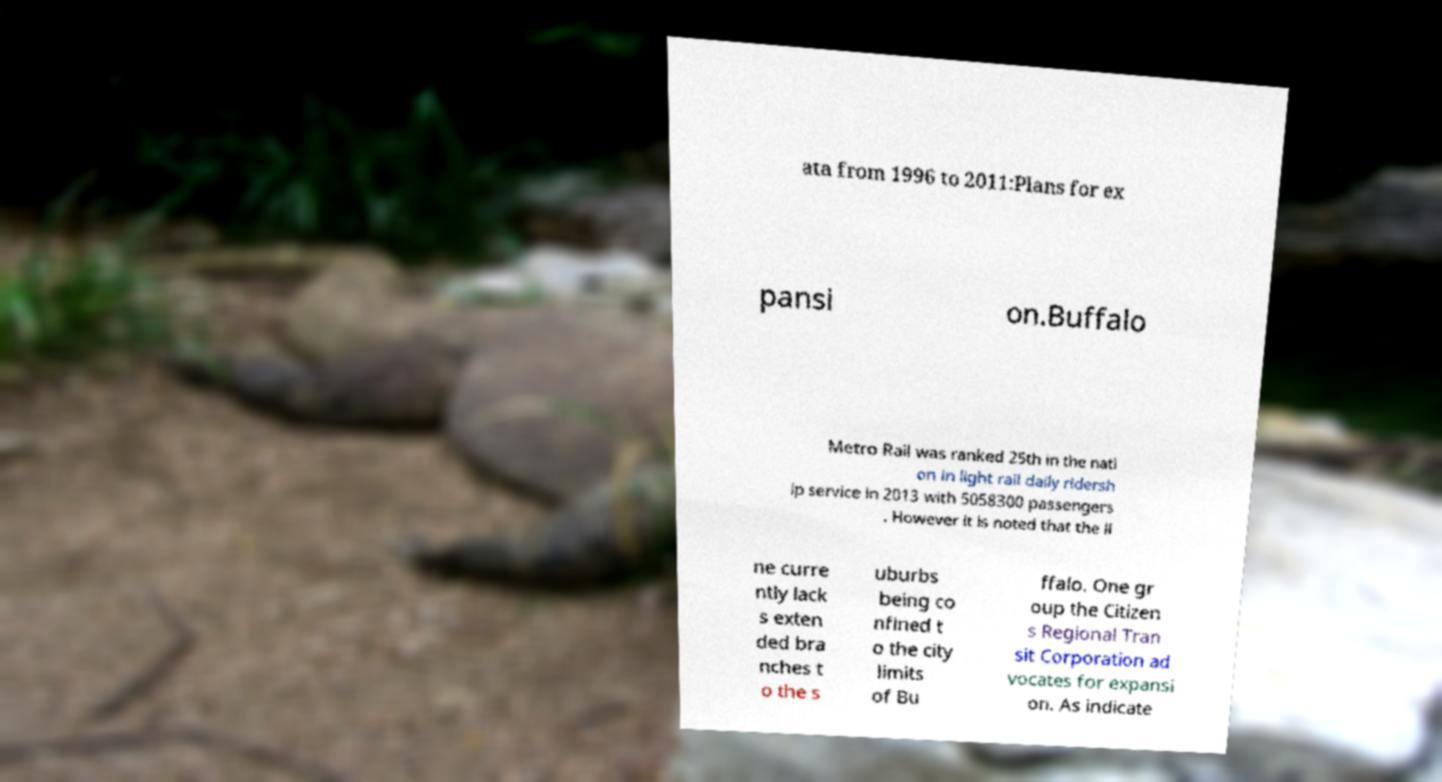There's text embedded in this image that I need extracted. Can you transcribe it verbatim? ata from 1996 to 2011:Plans for ex pansi on.Buffalo Metro Rail was ranked 25th in the nati on in light rail daily ridersh ip service in 2013 with 5058300 passengers . However it is noted that the li ne curre ntly lack s exten ded bra nches t o the s uburbs being co nfined t o the city limits of Bu ffalo. One gr oup the Citizen s Regional Tran sit Corporation ad vocates for expansi on. As indicate 